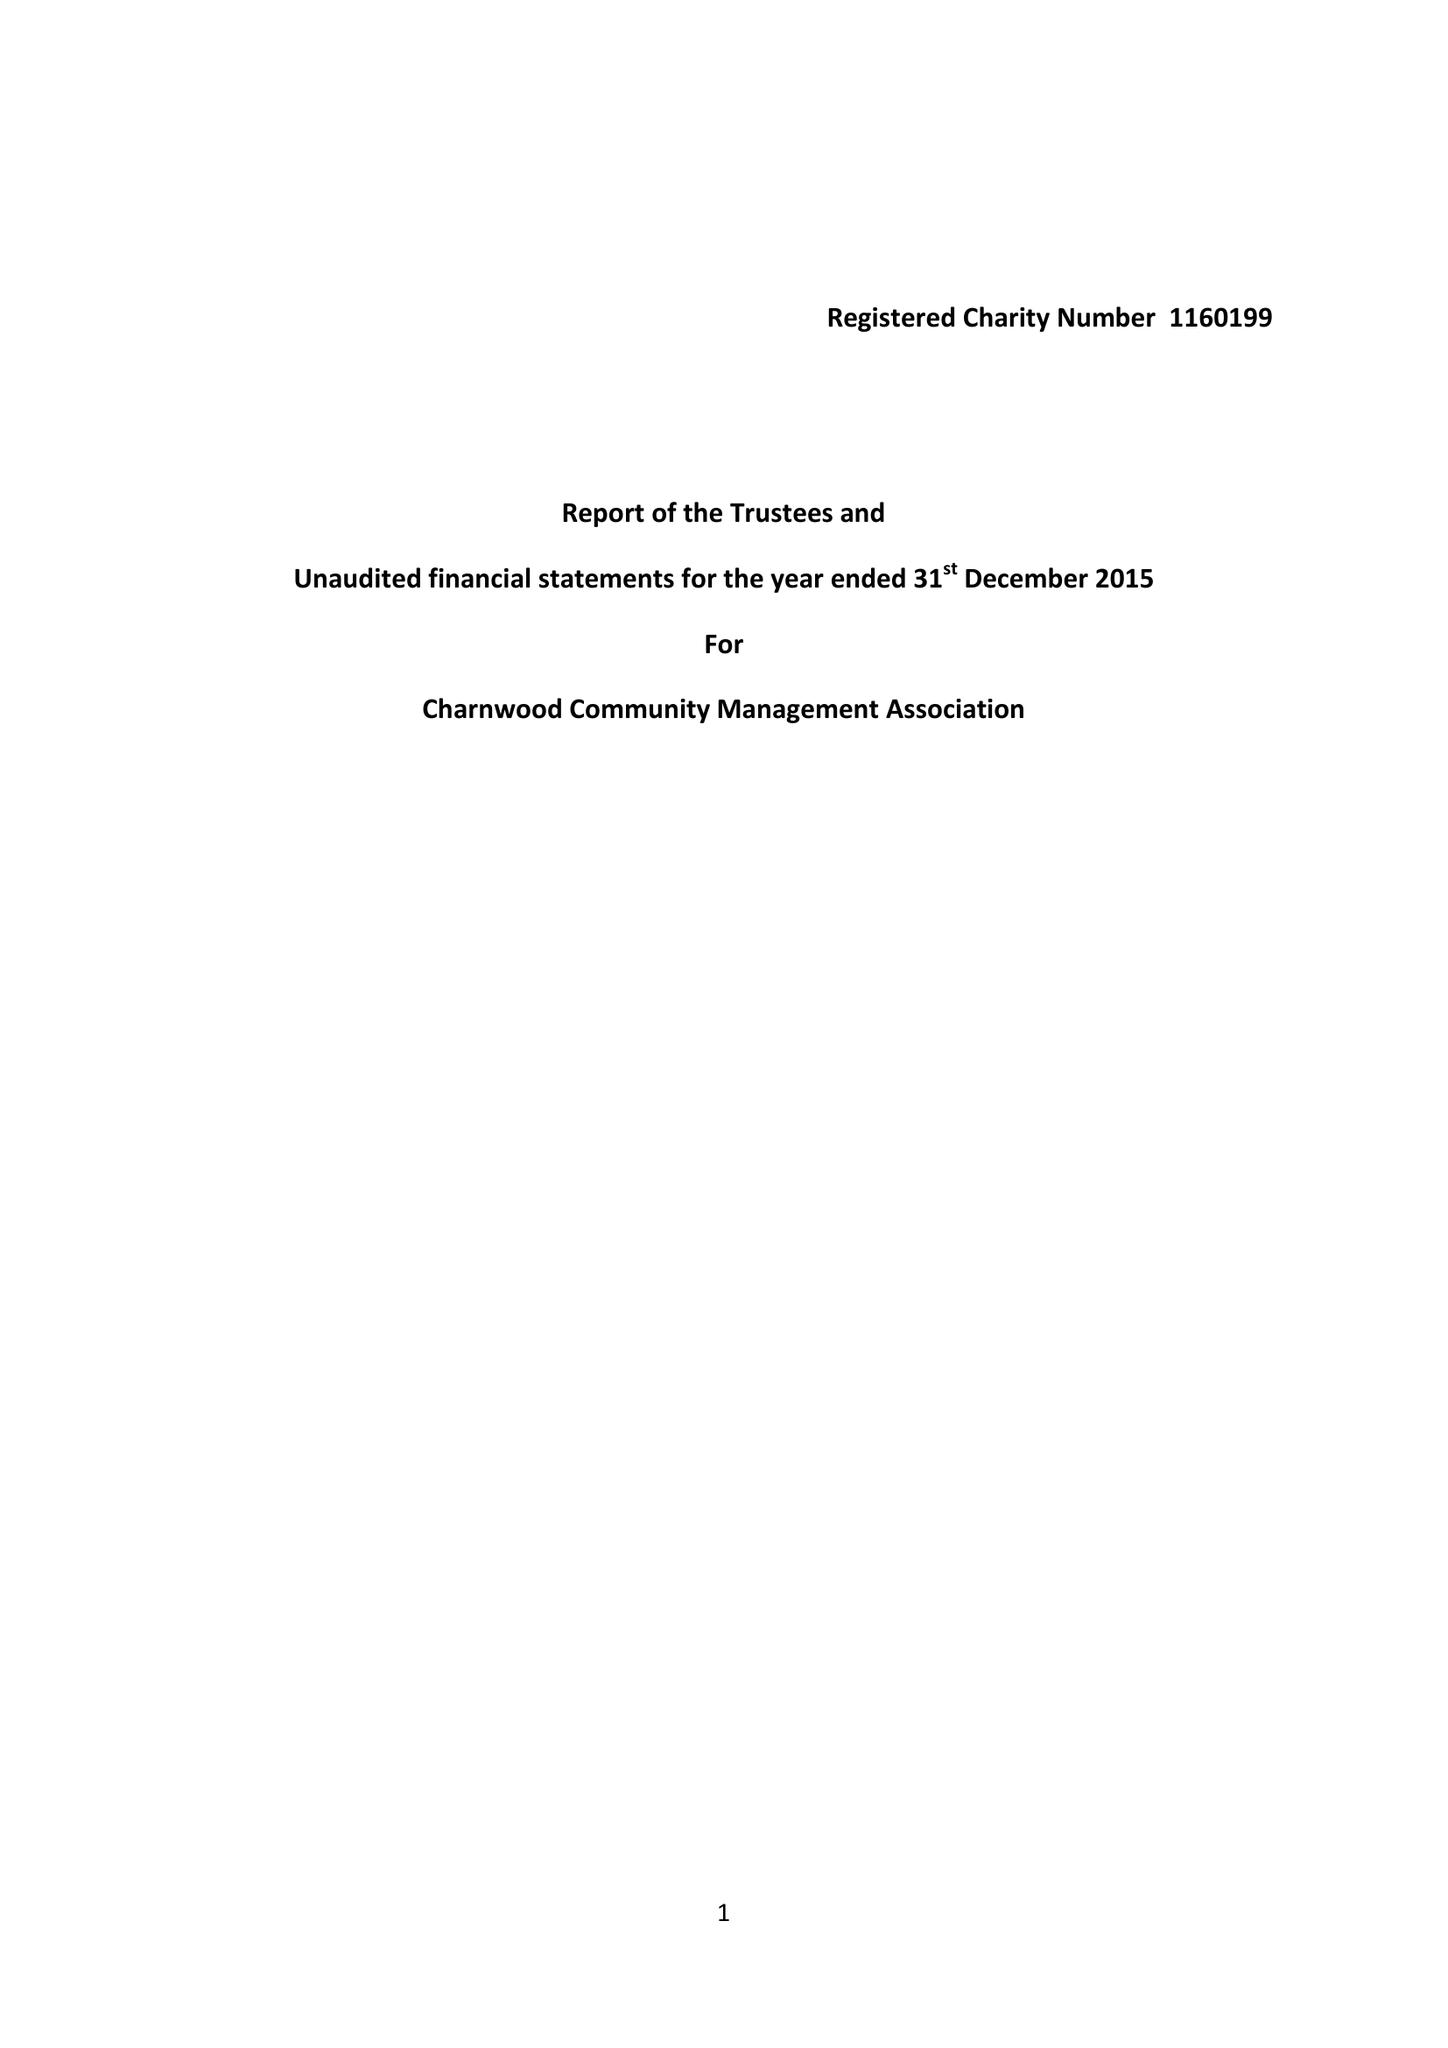What is the value for the address__post_town?
Answer the question using a single word or phrase. HITCHIN 